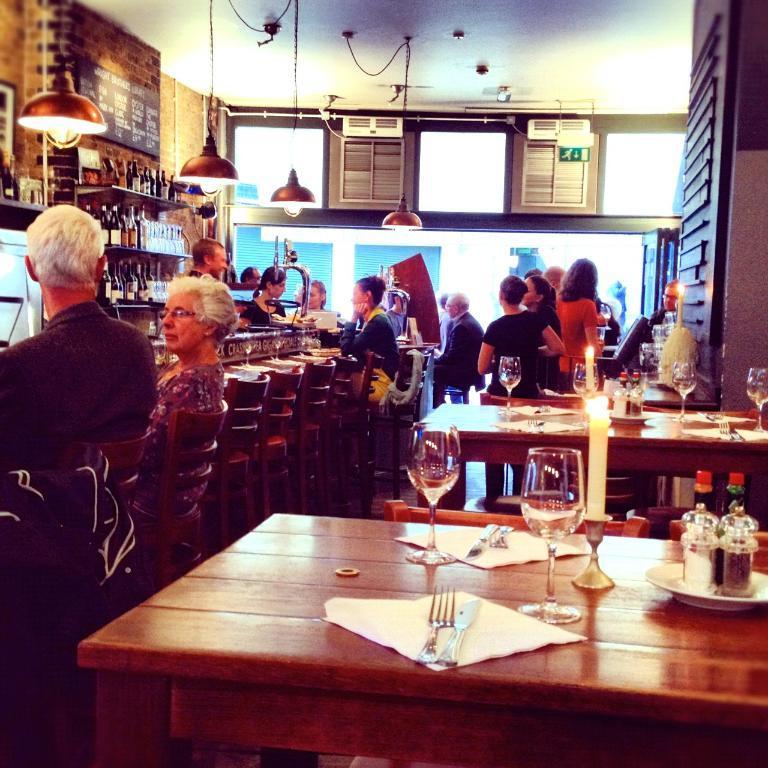Please provide a concise description of this image. In this picture we can see some people sitting on chairs and some people standing here, in front we can see a table which consist of a knife and fork, also we can see glass of drink, on right side we can see plate, on the left side of this image there are some bottles, on the top of the image we can see some lights here. 